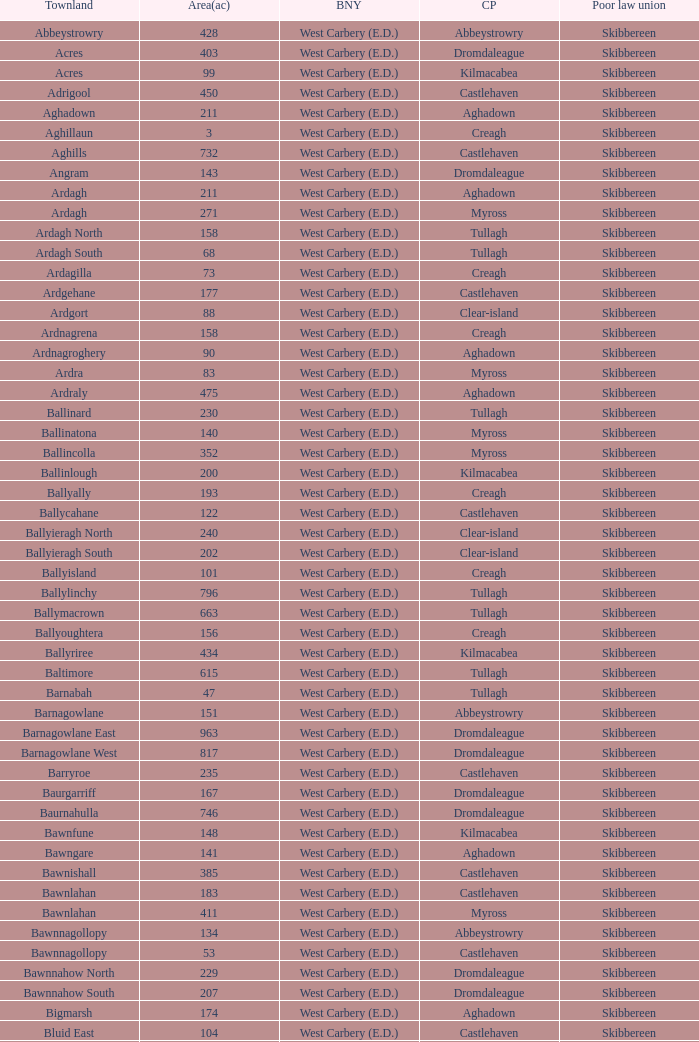What are the areas (in acres) of the Kilnahera East townland? 257.0. 